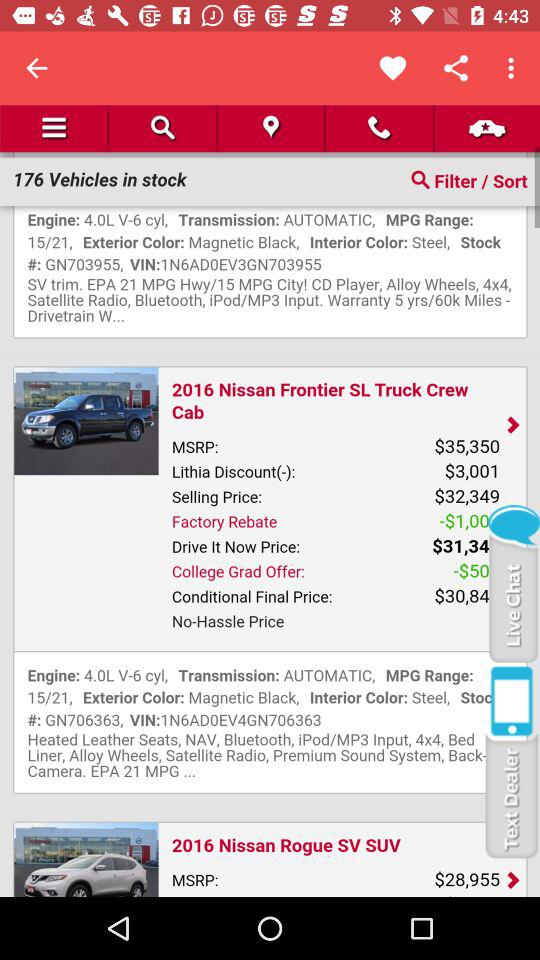What is the selling price of the "2016 Nissan Frontier SL Truck Crew Cab"? The selling price is $32,349. 